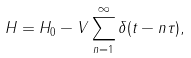<formula> <loc_0><loc_0><loc_500><loc_500>H = H _ { 0 } - V \sum _ { n = 1 } ^ { \infty } \delta ( t - n \tau ) ,</formula> 